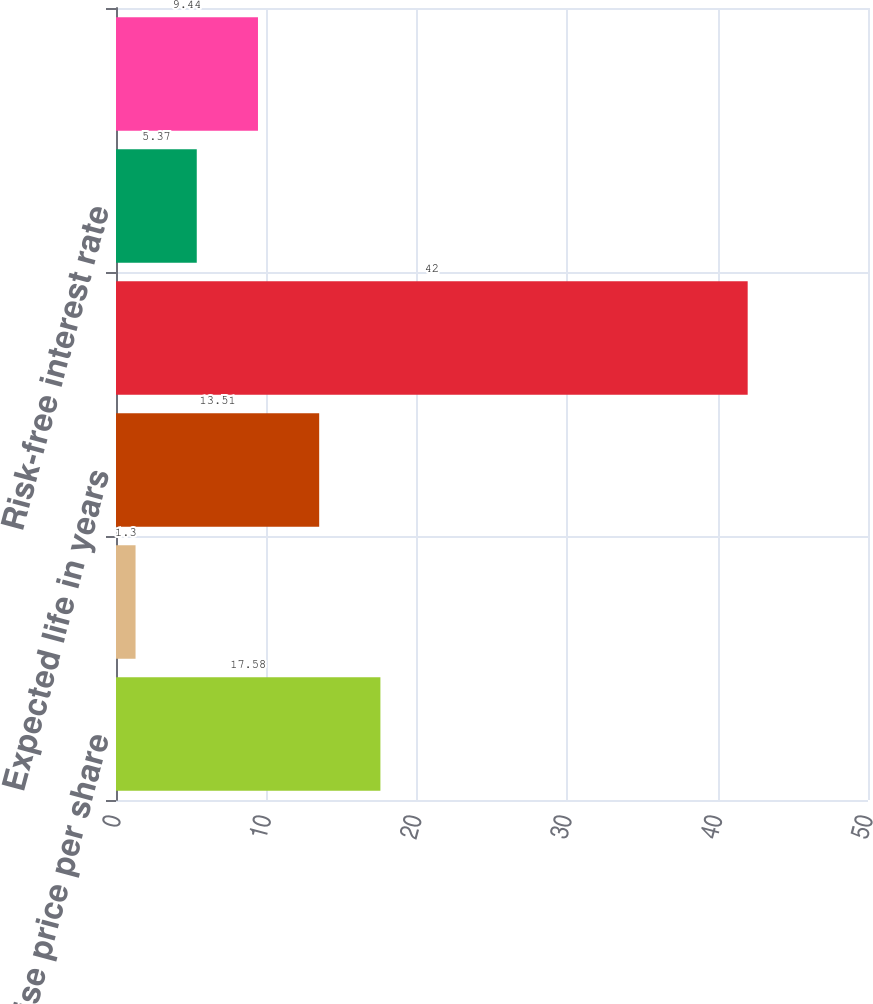Convert chart to OTSL. <chart><loc_0><loc_0><loc_500><loc_500><bar_chart><fcel>Exercise price per share<fcel>Expected annual dividend yield<fcel>Expected life in years<fcel>Expected volatility<fcel>Risk-free interest rate<fcel>Weighted average grant date<nl><fcel>17.58<fcel>1.3<fcel>13.51<fcel>42<fcel>5.37<fcel>9.44<nl></chart> 